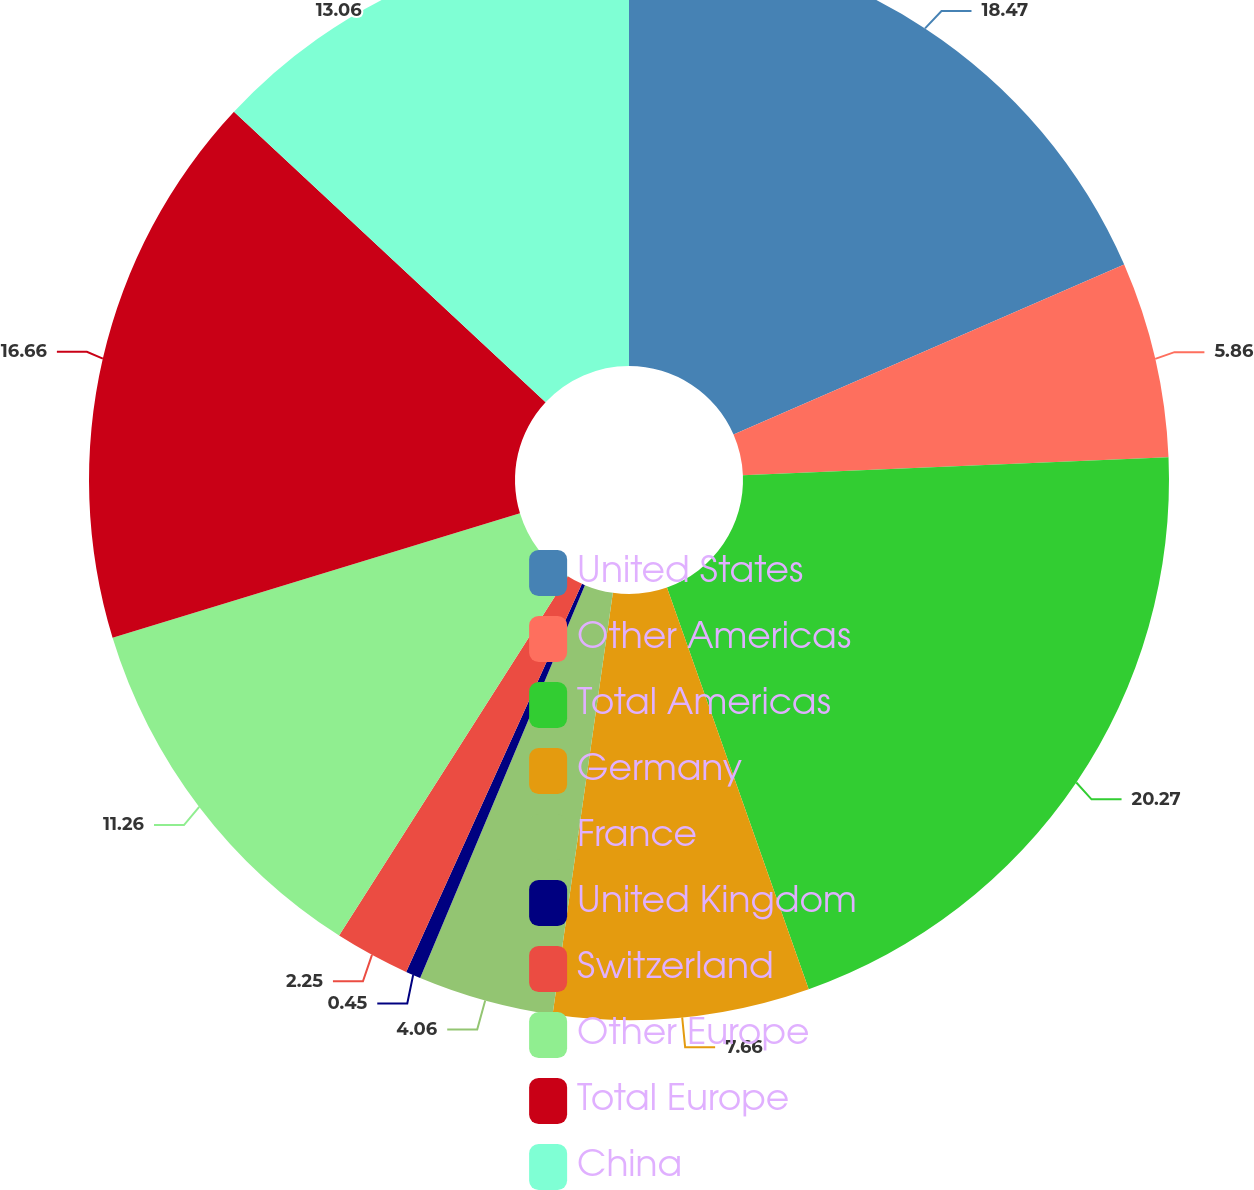<chart> <loc_0><loc_0><loc_500><loc_500><pie_chart><fcel>United States<fcel>Other Americas<fcel>Total Americas<fcel>Germany<fcel>France<fcel>United Kingdom<fcel>Switzerland<fcel>Other Europe<fcel>Total Europe<fcel>China<nl><fcel>18.47%<fcel>5.86%<fcel>20.27%<fcel>7.66%<fcel>4.06%<fcel>0.45%<fcel>2.25%<fcel>11.26%<fcel>16.66%<fcel>13.06%<nl></chart> 